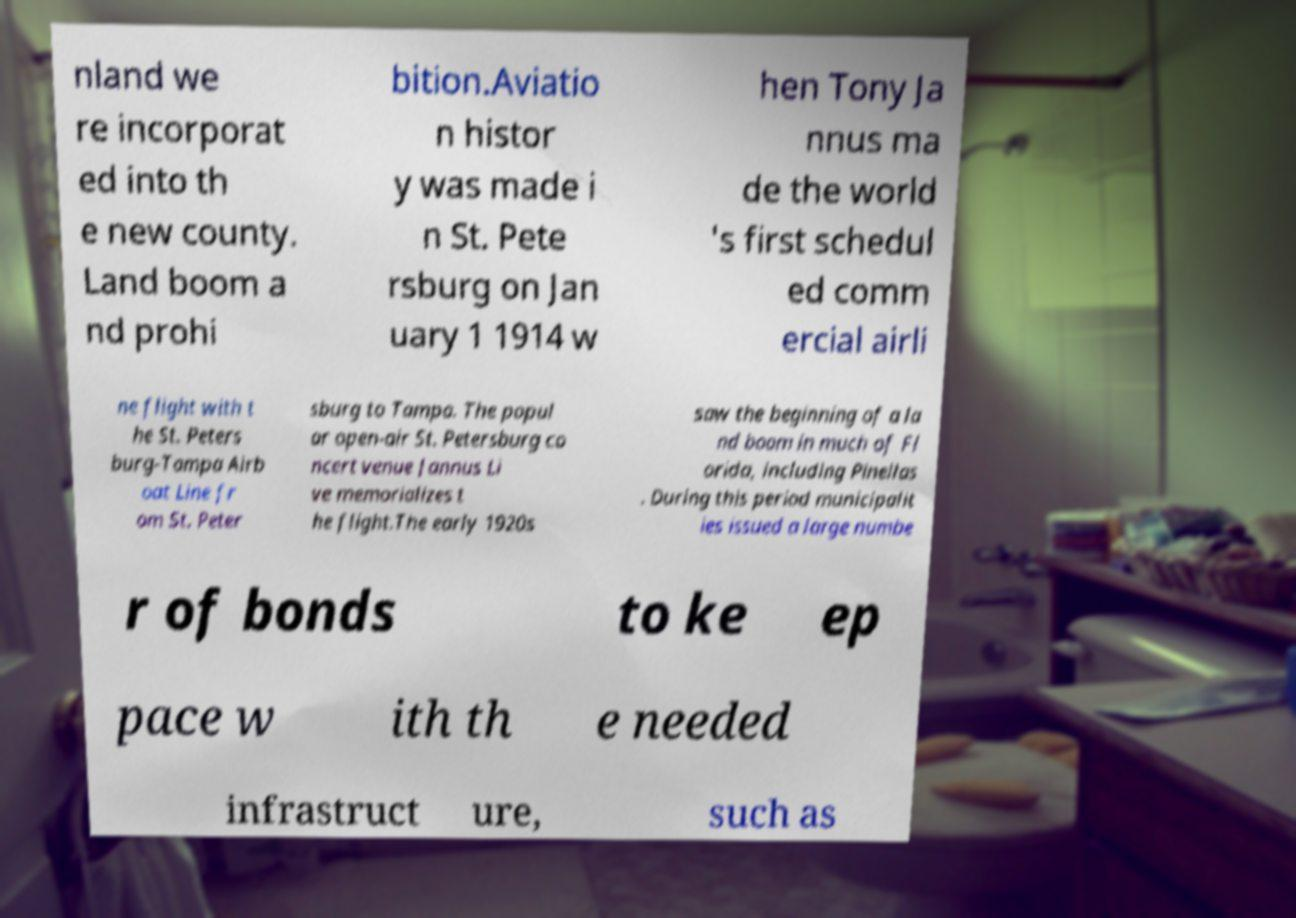Could you extract and type out the text from this image? nland we re incorporat ed into th e new county. Land boom a nd prohi bition.Aviatio n histor y was made i n St. Pete rsburg on Jan uary 1 1914 w hen Tony Ja nnus ma de the world 's first schedul ed comm ercial airli ne flight with t he St. Peters burg-Tampa Airb oat Line fr om St. Peter sburg to Tampa. The popul ar open-air St. Petersburg co ncert venue Jannus Li ve memorializes t he flight.The early 1920s saw the beginning of a la nd boom in much of Fl orida, including Pinellas . During this period municipalit ies issued a large numbe r of bonds to ke ep pace w ith th e needed infrastruct ure, such as 